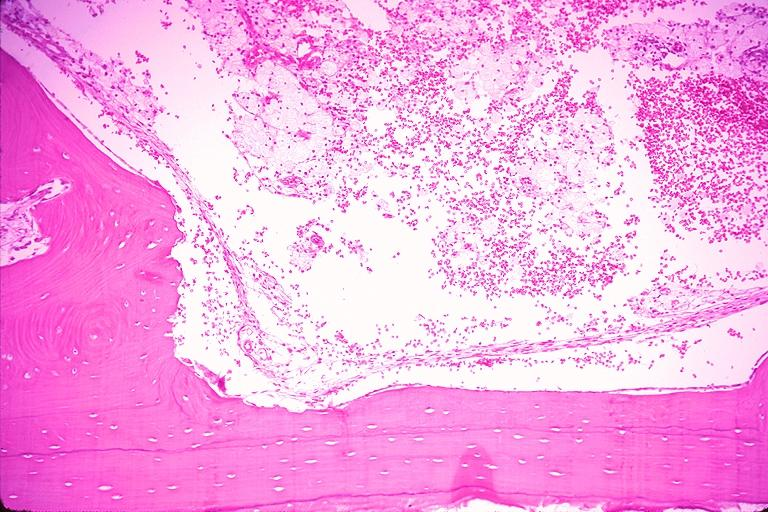s oral present?
Answer the question using a single word or phrase. Yes 